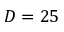<formula> <loc_0><loc_0><loc_500><loc_500>D = 2 5</formula> 